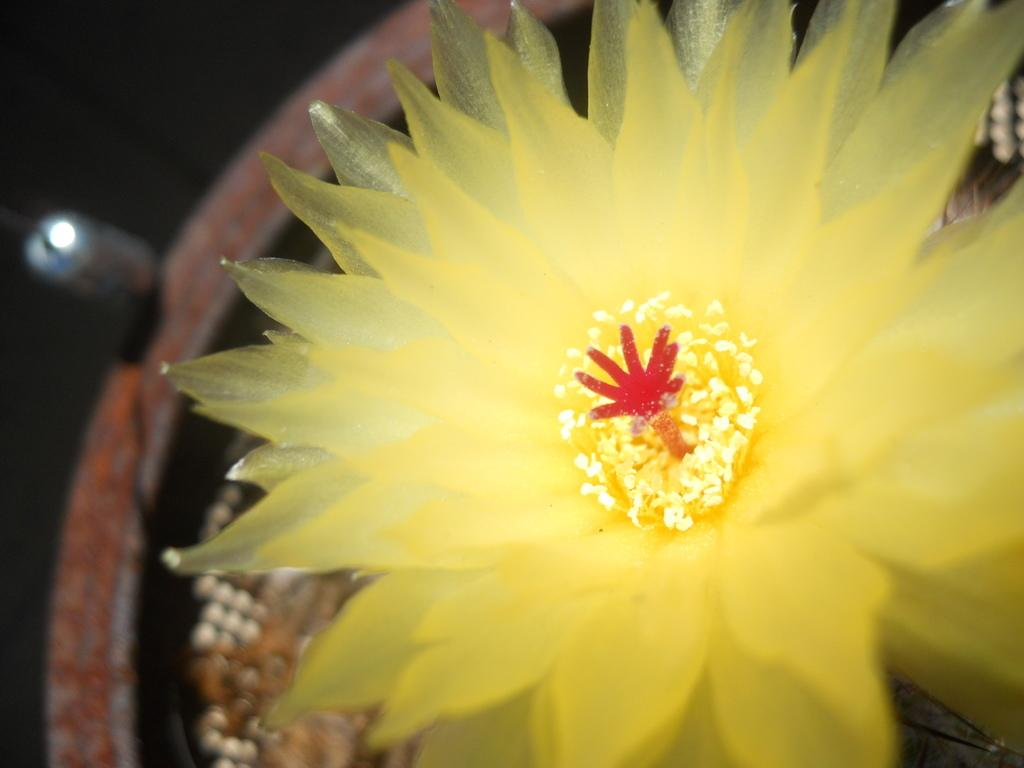What type of flower is in the image? There is a yellow flower in the image. Where is the flower pot located in the image? The flower pot is on the left side of the image. What can be seen in the background of the image? There is a light in the background of the image. What is the color of the background in the image? The background of the image has a black color. What type of toys are scattered around the yellow flower in the image? There are no toys present in the image; it only features a yellow flower and a flower pot. Is there a kite flying in the background of the image? There is no kite present in the image; the background only has a light and a black color. 